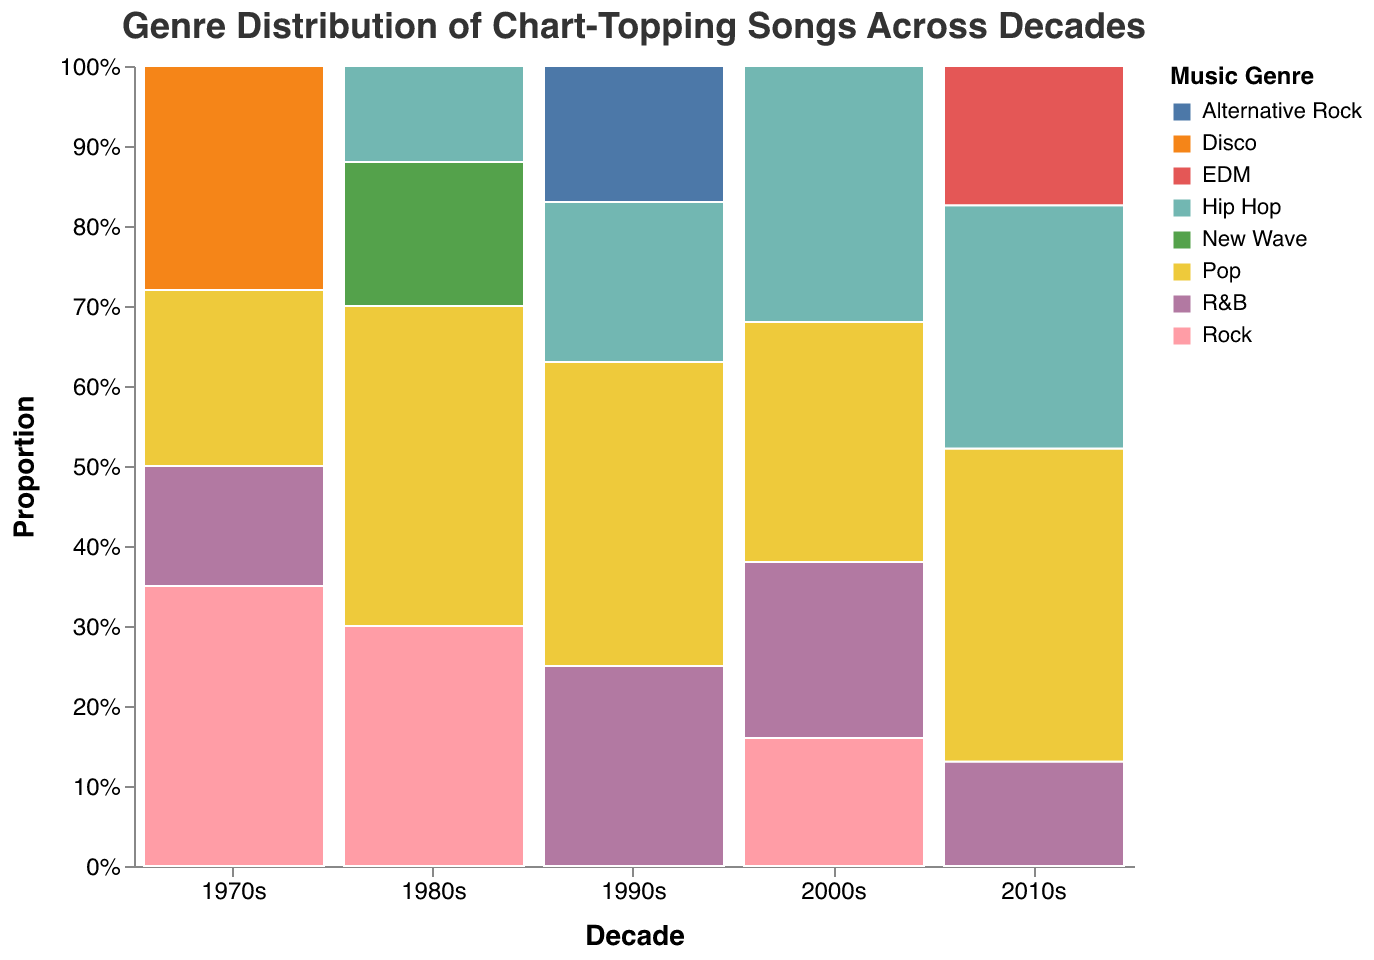What is the most dominant genre in the 1970s? Look for the genre with the largest proportional section within the 1970s decade on the mosaic plot. The largest proportion in the 1970s is "Rock".
Answer: Rock Does Pop increase its share of chart-topping songs over each decade from the 1970s to the 2010s? Examine the proportional size of the Pop segments in each decade from the 1970s to the 2010s. In the 1970s, Pop appears smaller than in subsequent decades, showing an increase in the 1980s, 1990s, 2000s, and peaking in the 2010s.
Answer: Yes Which genre shows the greatest proportional increase from one decade to the next? Compare all genres' proportional changes between consecutive decades. Hip Hop shows a marked increase from the 1980s to the 1990s and from the 1990s to the 2000s, making it the genre with the greatest increase over time.
Answer: Hip Hop How does the proportion of R&B songs change from the 1990s to the 2010s? Check the size of the R&B sections for the 1990s, 2000s, and 2010s. R&B shows a proportional decrease over these decades. It has a notable proportion in the 1990s, a smaller one in the 2000s, and even smaller in the 2010s.
Answer: Decreases Which decade has the most diverse genre distribution? Look for the decade where the mosaic plot shows relatively equal-sized sections for multiple genres. The 1970s have multiple genres (Rock, Disco, Pop, R&B) with significant shares, indicating the most diversity.
Answer: 1970s What genre entirely disappears from the top charts after its initial appearance in the 1980s? Identify the genres in the 1980s that are not present in later decades. "New Wave" only appears in the 1980s and is absent in following decades.
Answer: New Wave Which decade has the highest proportion of Hip Hop songs? Compare the proportional segments of Hip Hop for the 1980s, 1990s, 2000s, and 2010s. The 2010s show the highest proportion for Hip Hop among these decades.
Answer: 2010s How does the Rock genre's presence change over the decades? Observe the changes in the proportional size of the Rock sections. Rock is dominant in the 1970s, sizeable in the 1980s, less so in the 1990s and 2000s, and nearly absent in the 2010s.
Answer: Decreases Between which two consecutive decades is the increase in Pop most noticeable? Compare the increase in Pop proportions between each pair of consecutive decades. The most noticeable increase occurs between the 2000s and the 2010s.
Answer: 2000s to 2010s Which decade has the smallest proportion of Rock songs? Identify the decade with the smallest proportional section representing Rock. The 2010s have the smallest proportion of Rock songs among all the decades.
Answer: 2010s 